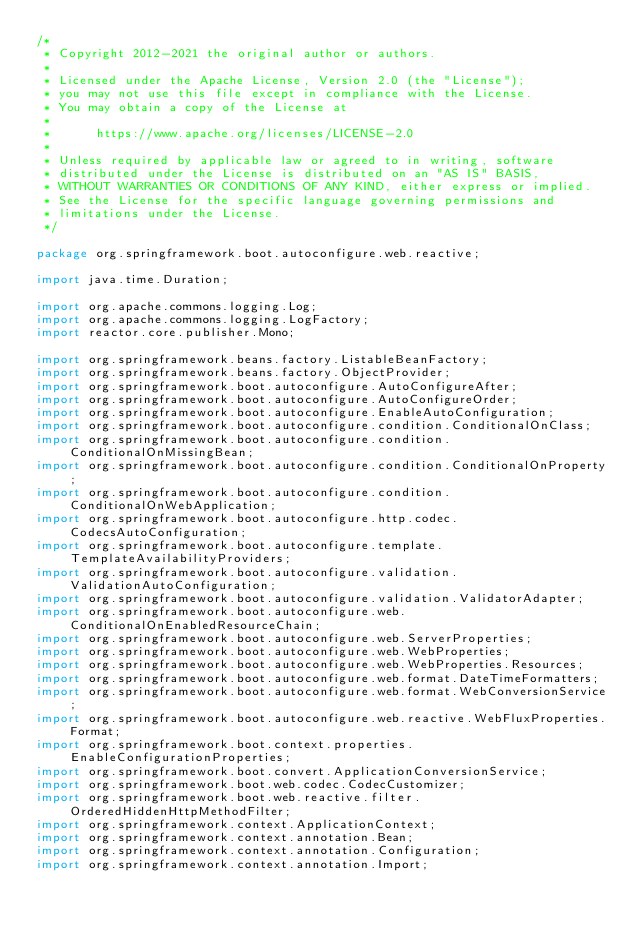Convert code to text. <code><loc_0><loc_0><loc_500><loc_500><_Java_>/*
 * Copyright 2012-2021 the original author or authors.
 *
 * Licensed under the Apache License, Version 2.0 (the "License");
 * you may not use this file except in compliance with the License.
 * You may obtain a copy of the License at
 *
 *      https://www.apache.org/licenses/LICENSE-2.0
 *
 * Unless required by applicable law or agreed to in writing, software
 * distributed under the License is distributed on an "AS IS" BASIS,
 * WITHOUT WARRANTIES OR CONDITIONS OF ANY KIND, either express or implied.
 * See the License for the specific language governing permissions and
 * limitations under the License.
 */

package org.springframework.boot.autoconfigure.web.reactive;

import java.time.Duration;

import org.apache.commons.logging.Log;
import org.apache.commons.logging.LogFactory;
import reactor.core.publisher.Mono;

import org.springframework.beans.factory.ListableBeanFactory;
import org.springframework.beans.factory.ObjectProvider;
import org.springframework.boot.autoconfigure.AutoConfigureAfter;
import org.springframework.boot.autoconfigure.AutoConfigureOrder;
import org.springframework.boot.autoconfigure.EnableAutoConfiguration;
import org.springframework.boot.autoconfigure.condition.ConditionalOnClass;
import org.springframework.boot.autoconfigure.condition.ConditionalOnMissingBean;
import org.springframework.boot.autoconfigure.condition.ConditionalOnProperty;
import org.springframework.boot.autoconfigure.condition.ConditionalOnWebApplication;
import org.springframework.boot.autoconfigure.http.codec.CodecsAutoConfiguration;
import org.springframework.boot.autoconfigure.template.TemplateAvailabilityProviders;
import org.springframework.boot.autoconfigure.validation.ValidationAutoConfiguration;
import org.springframework.boot.autoconfigure.validation.ValidatorAdapter;
import org.springframework.boot.autoconfigure.web.ConditionalOnEnabledResourceChain;
import org.springframework.boot.autoconfigure.web.ServerProperties;
import org.springframework.boot.autoconfigure.web.WebProperties;
import org.springframework.boot.autoconfigure.web.WebProperties.Resources;
import org.springframework.boot.autoconfigure.web.format.DateTimeFormatters;
import org.springframework.boot.autoconfigure.web.format.WebConversionService;
import org.springframework.boot.autoconfigure.web.reactive.WebFluxProperties.Format;
import org.springframework.boot.context.properties.EnableConfigurationProperties;
import org.springframework.boot.convert.ApplicationConversionService;
import org.springframework.boot.web.codec.CodecCustomizer;
import org.springframework.boot.web.reactive.filter.OrderedHiddenHttpMethodFilter;
import org.springframework.context.ApplicationContext;
import org.springframework.context.annotation.Bean;
import org.springframework.context.annotation.Configuration;
import org.springframework.context.annotation.Import;</code> 